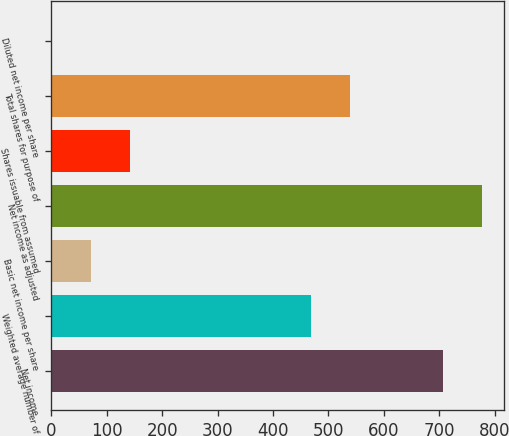Convert chart. <chart><loc_0><loc_0><loc_500><loc_500><bar_chart><fcel>Net income<fcel>Weighted average number of<fcel>Basic net income per share<fcel>Net income as adjusted<fcel>Shares issuable from assumed<fcel>Total shares for purpose of<fcel>Diluted net income per share<nl><fcel>707<fcel>468<fcel>71.97<fcel>777.56<fcel>142.53<fcel>538.56<fcel>1.41<nl></chart> 